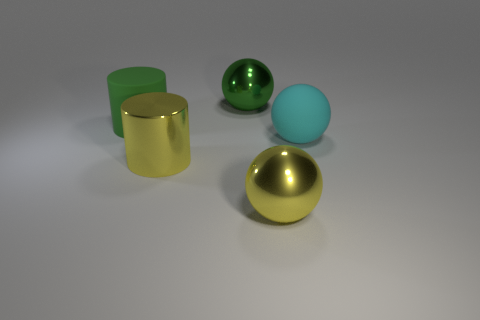The metallic thing that is the same color as the shiny cylinder is what shape?
Ensure brevity in your answer.  Sphere. What number of shiny objects are the same color as the large matte cylinder?
Provide a succinct answer. 1. There is a cylinder that is made of the same material as the cyan sphere; what is its size?
Make the answer very short. Large. Are there any balls behind the large green rubber thing?
Give a very brief answer. Yes. The green metallic object that is the same shape as the large cyan thing is what size?
Offer a terse response. Large. There is a large metal cylinder; does it have the same color as the large shiny ball in front of the large green rubber cylinder?
Offer a very short reply. Yes. Is the color of the large matte cylinder the same as the metal cylinder?
Ensure brevity in your answer.  No. Are there fewer yellow metal spheres than big objects?
Your answer should be very brief. Yes. What number of other things are there of the same color as the large matte sphere?
Provide a short and direct response. 0. What number of balls are there?
Your response must be concise. 3. 